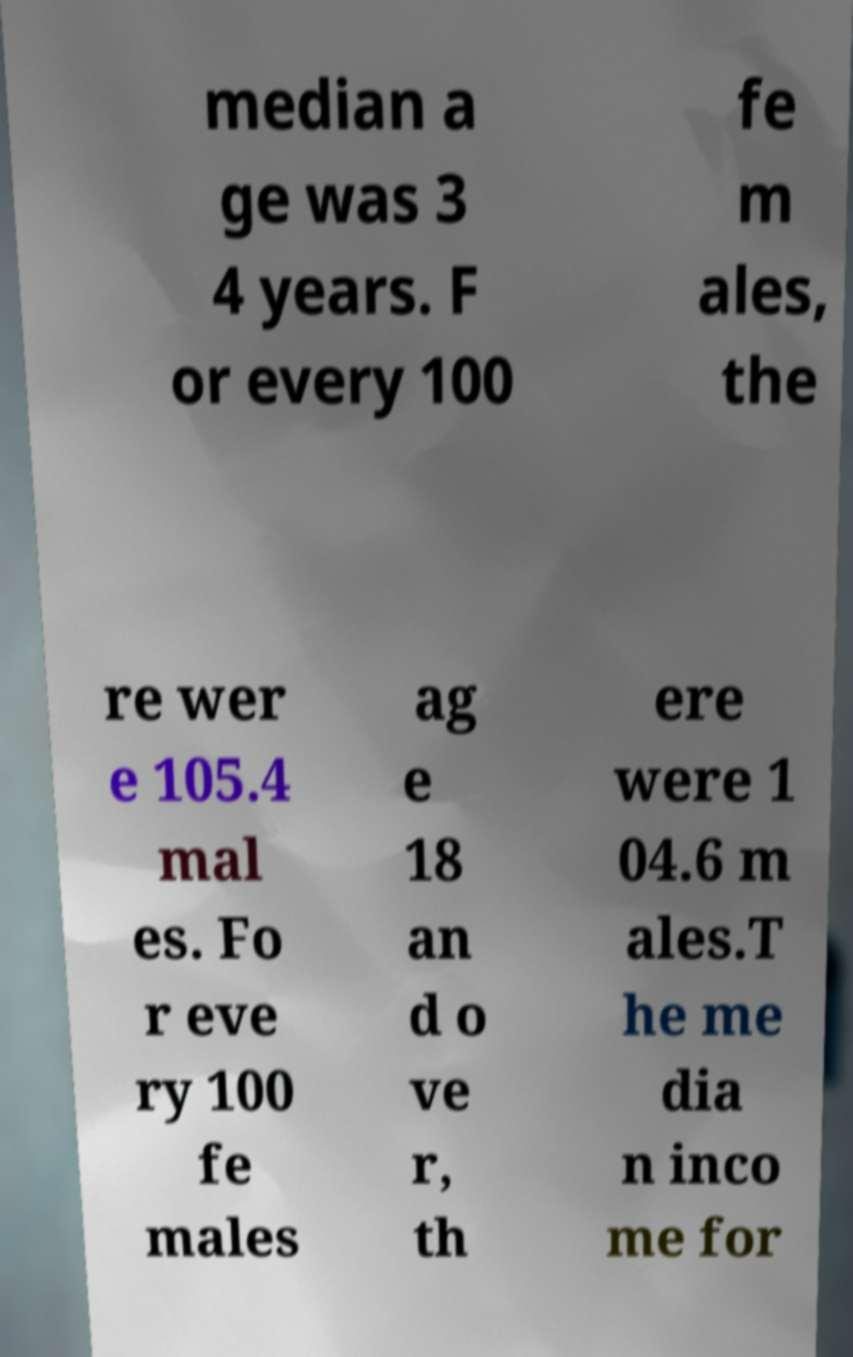For documentation purposes, I need the text within this image transcribed. Could you provide that? median a ge was 3 4 years. F or every 100 fe m ales, the re wer e 105.4 mal es. Fo r eve ry 100 fe males ag e 18 an d o ve r, th ere were 1 04.6 m ales.T he me dia n inco me for 